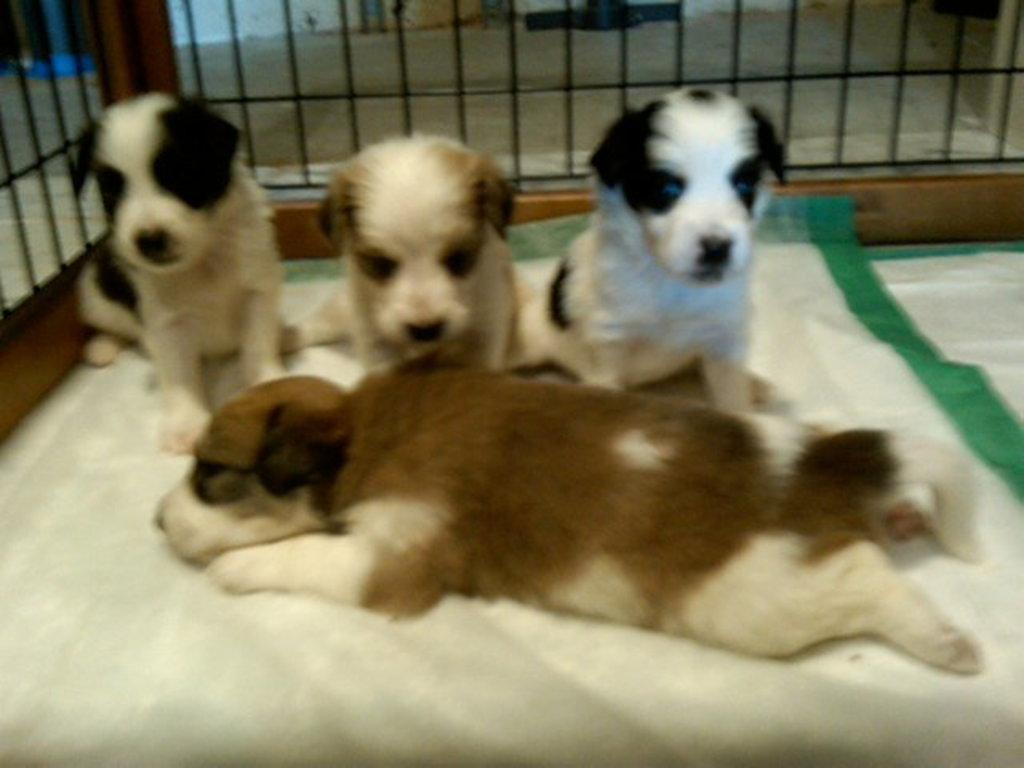How many dogs are in the image? There are four dogs in the image. What are the colors of the dogs? The dogs have different colors: brown, cream, black, and white. What is the surface the dogs are on? The dogs are on a white-colored surface. What can be seen in the background of the image? There is a black-colored fence in the image. What part of the environment is visible in the image? The floor is visible in the image. What trick does the sister perform with the fuel in the image? A: There is no sister or fuel present in the image; it features four dogs on a white surface with a black-colored fence in the background. 